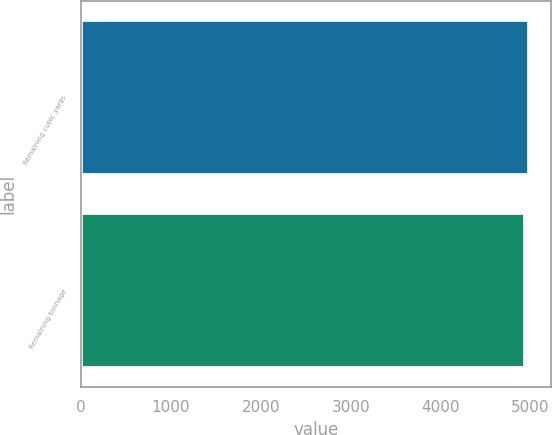Convert chart. <chart><loc_0><loc_0><loc_500><loc_500><bar_chart><fcel>Remaining cubic yards<fcel>Remaining tonnage<nl><fcel>4983<fcel>4935<nl></chart> 